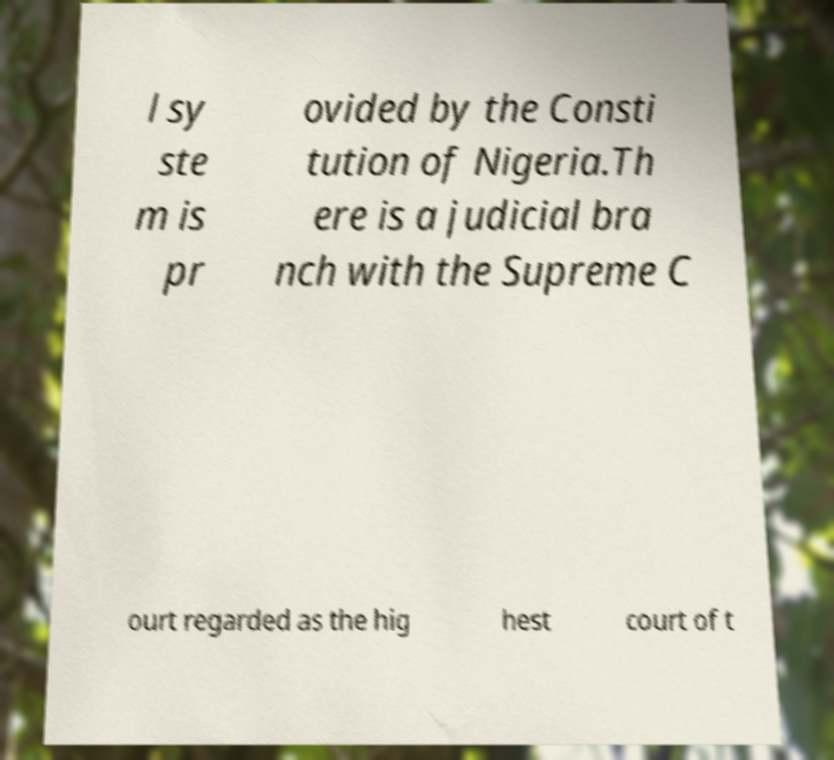For documentation purposes, I need the text within this image transcribed. Could you provide that? l sy ste m is pr ovided by the Consti tution of Nigeria.Th ere is a judicial bra nch with the Supreme C ourt regarded as the hig hest court of t 